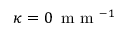Convert formula to latex. <formula><loc_0><loc_0><loc_500><loc_500>\kappa = 0 \, m m ^ { - 1 }</formula> 